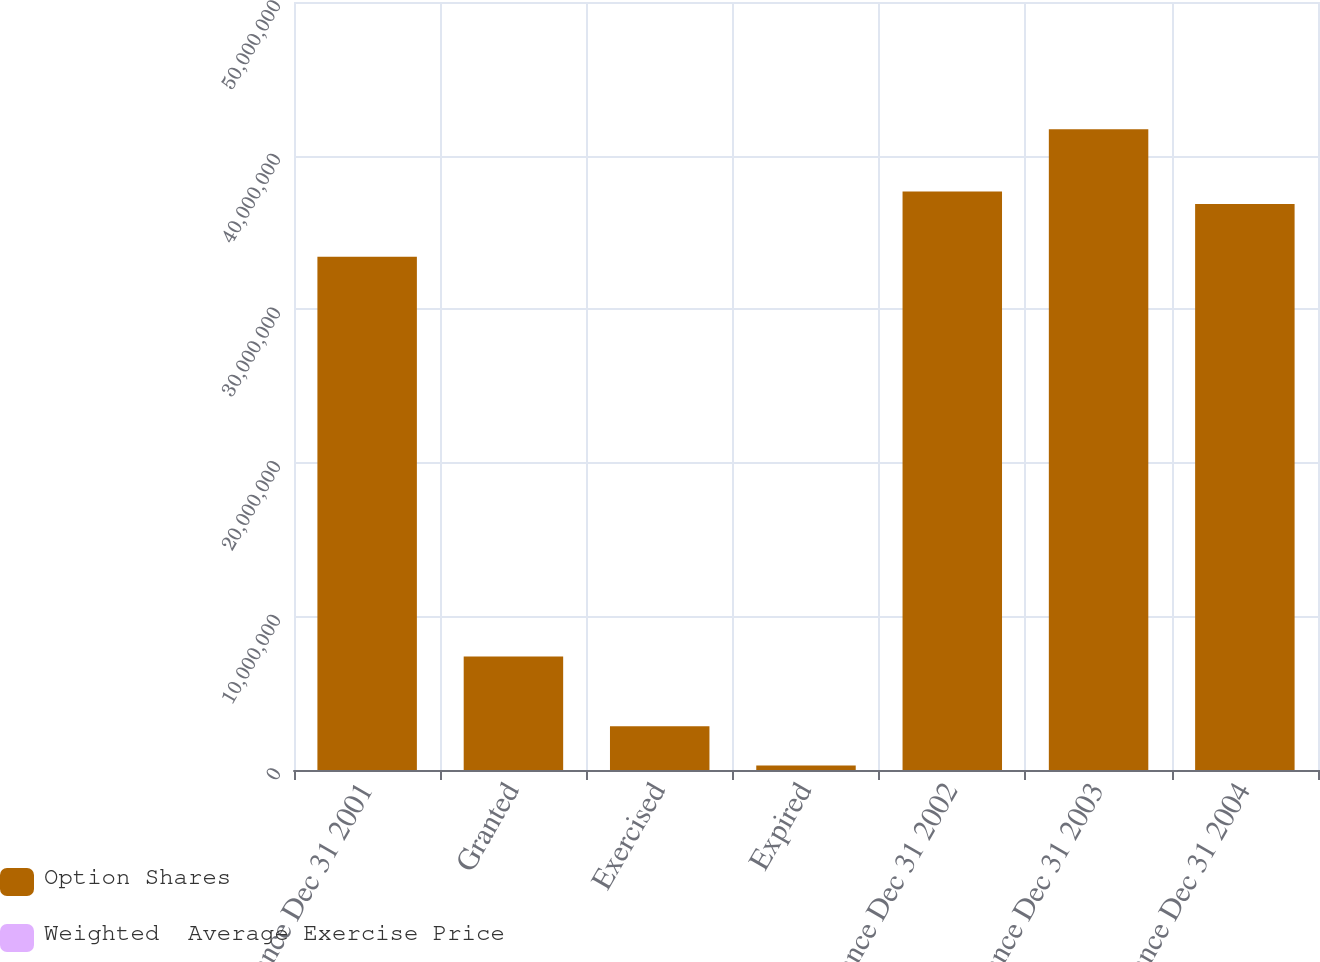<chart> <loc_0><loc_0><loc_500><loc_500><stacked_bar_chart><ecel><fcel>Balance Dec 31 2001<fcel>Granted<fcel>Exercised<fcel>Expired<fcel>Balance Dec 31 2002<fcel>Balance Dec 31 2003<fcel>Balance Dec 31 2004<nl><fcel>Option Shares<fcel>3.34135e+07<fcel>7.384e+06<fcel>2.85154e+06<fcel>287341<fcel>3.76586e+07<fcel>4.17138e+07<fcel>3.68569e+07<nl><fcel>Weighted  Average Exercise Price<fcel>23.21<fcel>22.49<fcel>17.48<fcel>26.73<fcel>23.47<fcel>23.07<fcel>23.66<nl></chart> 